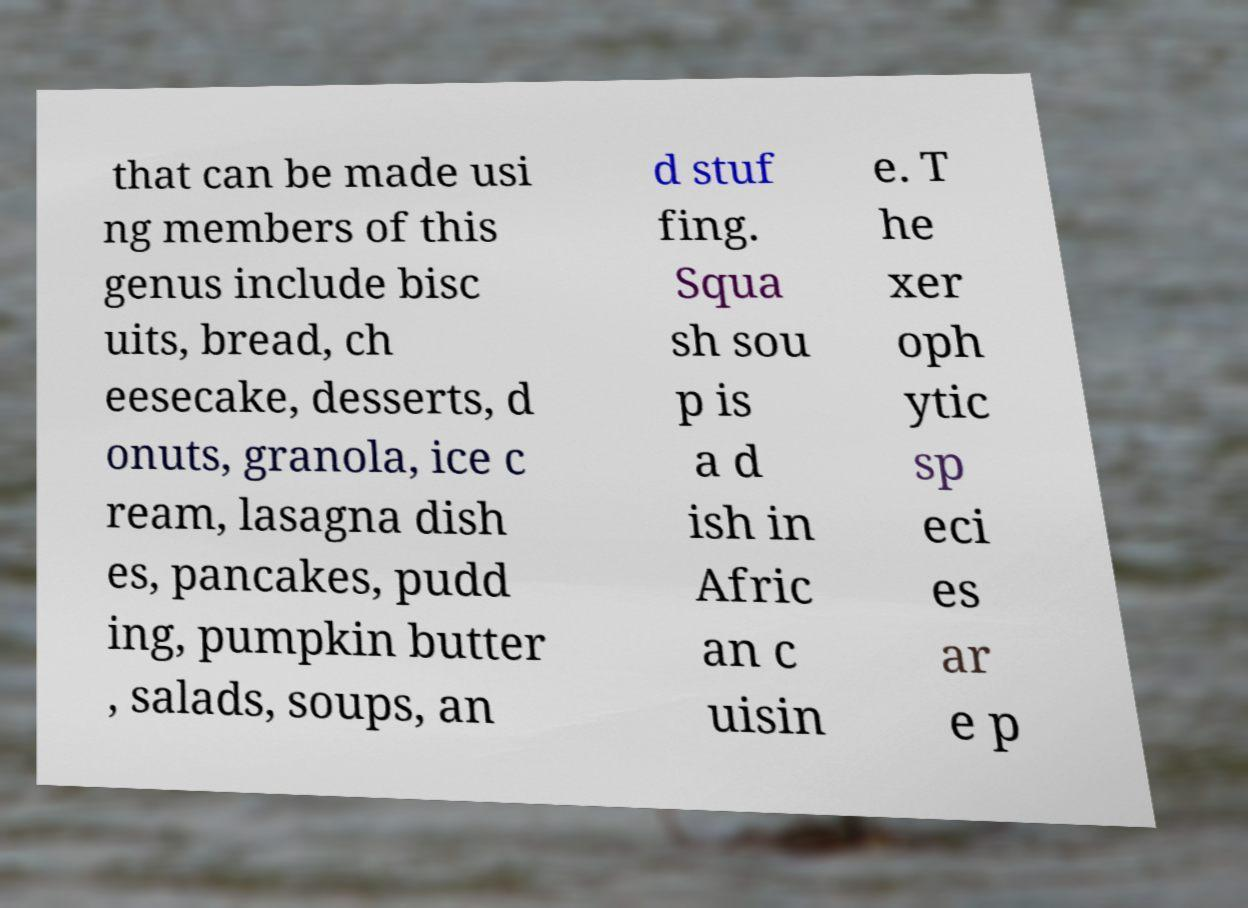For documentation purposes, I need the text within this image transcribed. Could you provide that? that can be made usi ng members of this genus include bisc uits, bread, ch eesecake, desserts, d onuts, granola, ice c ream, lasagna dish es, pancakes, pudd ing, pumpkin butter , salads, soups, an d stuf fing. Squa sh sou p is a d ish in Afric an c uisin e. T he xer oph ytic sp eci es ar e p 